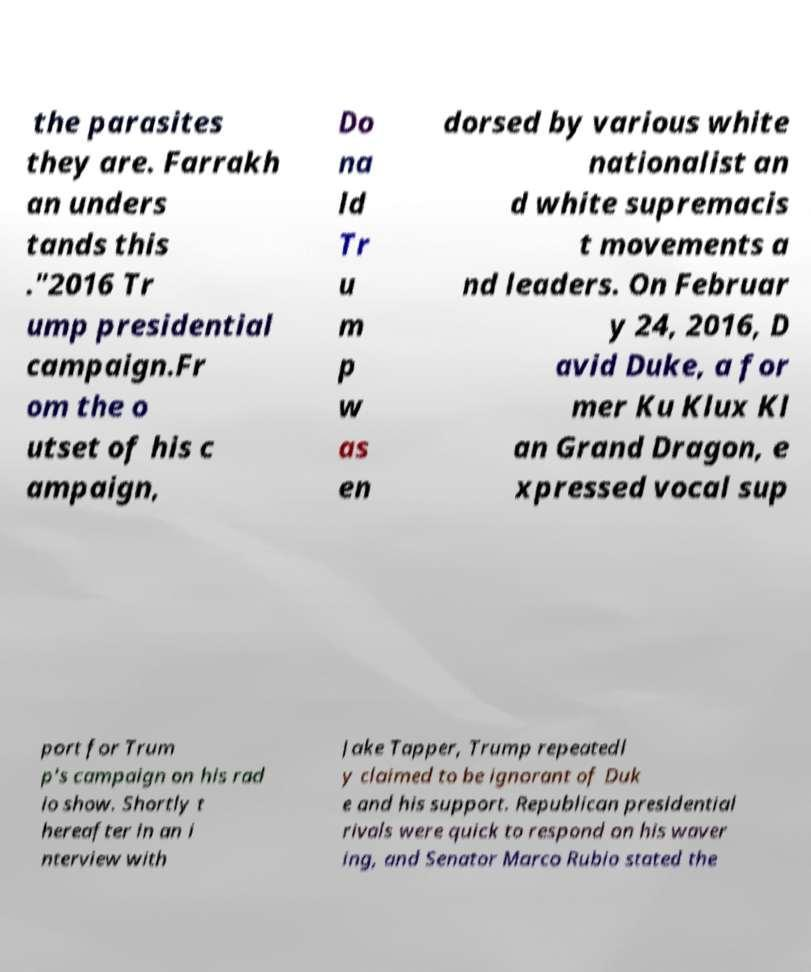Please read and relay the text visible in this image. What does it say? the parasites they are. Farrakh an unders tands this ."2016 Tr ump presidential campaign.Fr om the o utset of his c ampaign, Do na ld Tr u m p w as en dorsed by various white nationalist an d white supremacis t movements a nd leaders. On Februar y 24, 2016, D avid Duke, a for mer Ku Klux Kl an Grand Dragon, e xpressed vocal sup port for Trum p's campaign on his rad io show. Shortly t hereafter in an i nterview with Jake Tapper, Trump repeatedl y claimed to be ignorant of Duk e and his support. Republican presidential rivals were quick to respond on his waver ing, and Senator Marco Rubio stated the 